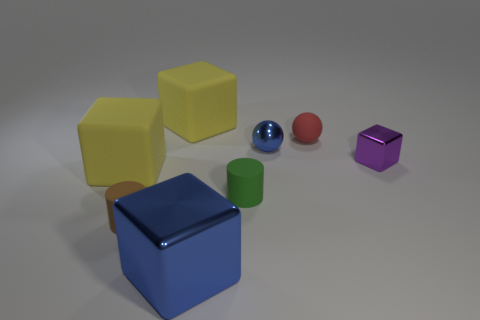Are there more tiny brown cylinders that are to the left of the big blue object than red rubber spheres to the left of the blue ball?
Your answer should be compact. Yes. What material is the small blue object?
Offer a very short reply. Metal. What shape is the big thing behind the purple object behind the big yellow matte cube left of the brown object?
Your answer should be compact. Cube. How many other things are there of the same material as the purple object?
Offer a terse response. 2. Does the blue cube in front of the brown thing have the same material as the blue thing that is behind the brown rubber thing?
Your answer should be very brief. Yes. How many objects are behind the small brown matte thing and on the left side of the big metallic cube?
Offer a very short reply. 2. Are there any small shiny things that have the same shape as the small brown rubber thing?
Provide a succinct answer. No. What shape is the other metallic object that is the same size as the purple metallic thing?
Provide a succinct answer. Sphere. Are there the same number of tiny green rubber things in front of the blue metal sphere and blue objects that are behind the tiny shiny cube?
Keep it short and to the point. Yes. What is the size of the sphere behind the blue metallic thing on the right side of the big blue metal block?
Provide a short and direct response. Small. 